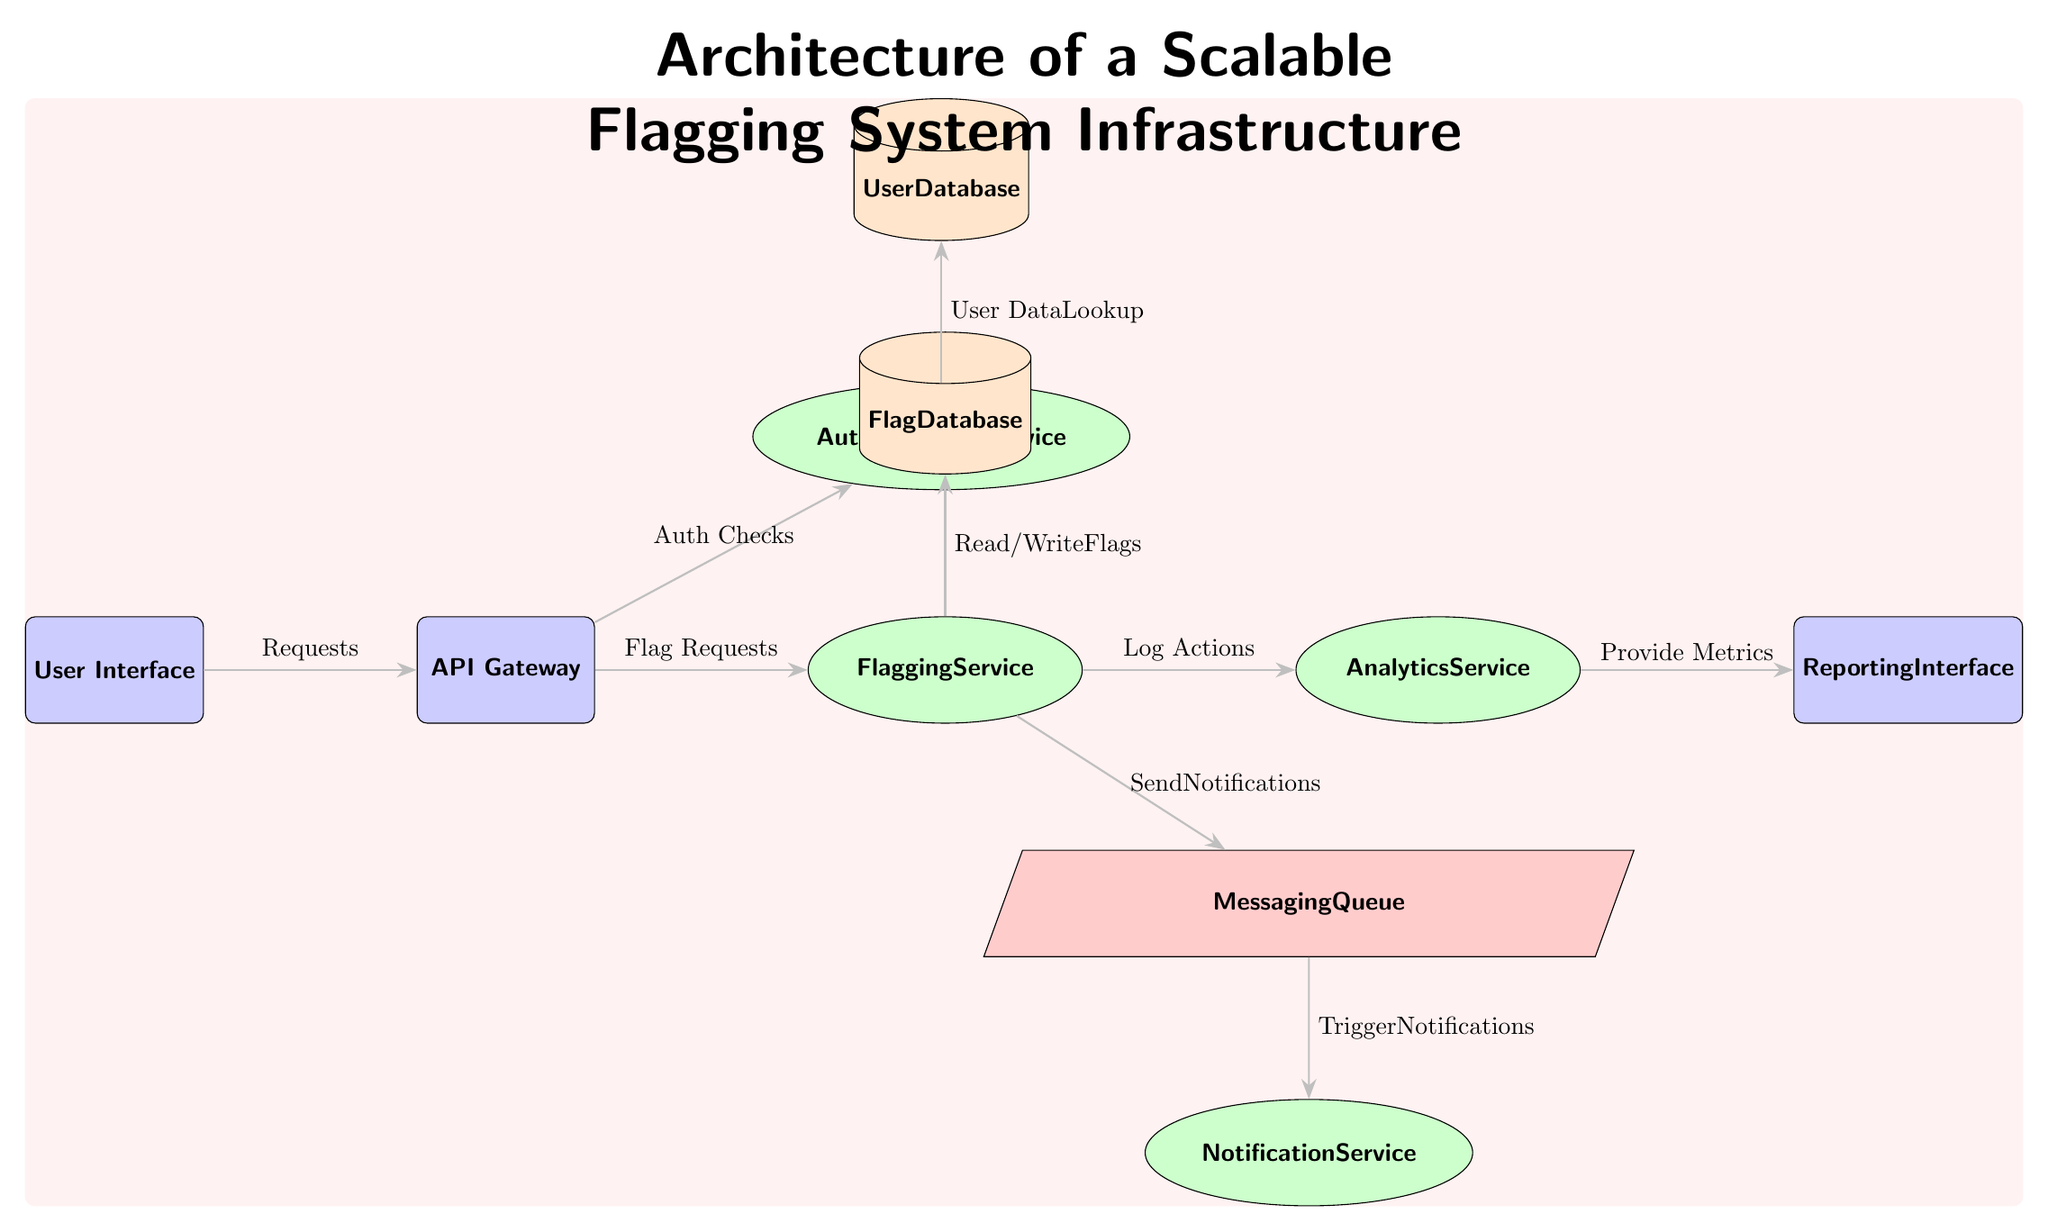What is the first component in the architecture? The first component located on the leftmost side of the diagram is the "User Interface".
Answer: User Interface How many services are present in the architecture? By examining the components, there are four services: Authentication Service, Flagging Service, Notification Service, and Analytics Service.
Answer: Four Which component is responsible for logging actions? The component that is responsible for logging actions, as indicated by the outgoing arrow, is the "Flagging Service" which connects to the "Analytics Service".
Answer: Flagging Service What type of database is used for user data? The database used for user data, as shown in the diagram, is represented as a cylinder and is labeled as "User Database".
Answer: User Database What does the Messaging Queue send? The Messaging Queue sends "Notifications" as depicted by the arrow originating from the Messaging Queue to the Notification Service, indicated by the label on the arrow.
Answer: Notifications Which two components are directly connected by the Flagging Service? The Flagging Service directly connects to the "Flag Database" and the "Messaging Queue" as indicated by the arrows directed from the Flagging Service to these components.
Answer: Flag Database and Messaging Queue What type of component is the API Gateway? The API Gateway is classified as a component and is represented with rounded corners and filled in blue in the diagram.
Answer: Component How many edges are connected to the Notification Service? The Notification Service has one edge connected to it, coming from the Messaging Queue, as indicated by the single arrow leading to this service.
Answer: One What action is associated with the connection from the Analytics Service to the Reporting Interface? The action associated with the connection from the Analytics Service to the Reporting Interface is to "Provide Metrics", as marked by the label next to the connecting arrow.
Answer: Provide Metrics 